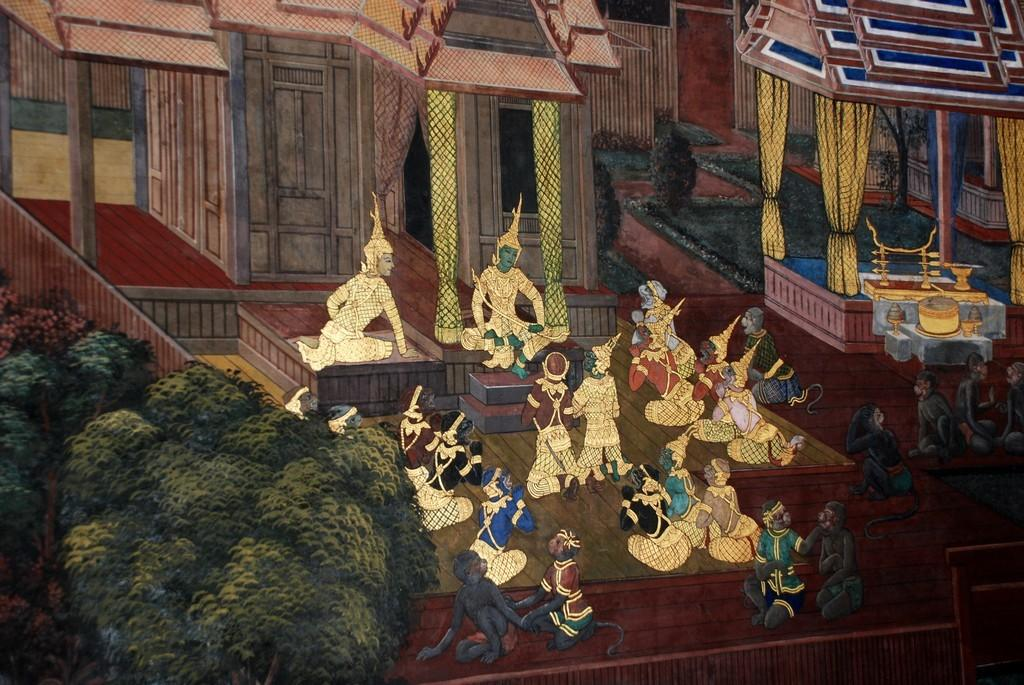What type of image is being described? The image is animated. What can be seen in the middle of the image? There are people in the middle of the image. What is located in the foreground of the image? There are buildings, curtains, objects, plants, and trees in the foreground of the image. What type of feeling can be seen on the cobweb in the image? There is no cobweb present in the image, so it is not possible to determine any feelings associated with it. 